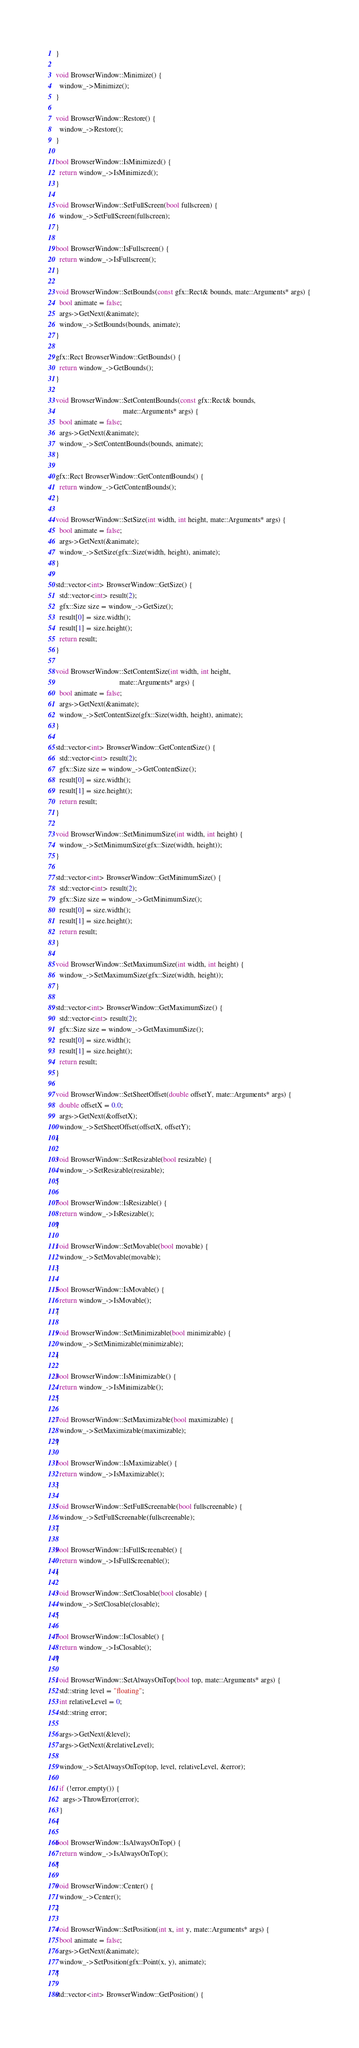Convert code to text. <code><loc_0><loc_0><loc_500><loc_500><_C++_>}

void BrowserWindow::Minimize() {
  window_->Minimize();
}

void BrowserWindow::Restore() {
  window_->Restore();
}

bool BrowserWindow::IsMinimized() {
  return window_->IsMinimized();
}

void BrowserWindow::SetFullScreen(bool fullscreen) {
  window_->SetFullScreen(fullscreen);
}

bool BrowserWindow::IsFullscreen() {
  return window_->IsFullscreen();
}

void BrowserWindow::SetBounds(const gfx::Rect& bounds, mate::Arguments* args) {
  bool animate = false;
  args->GetNext(&animate);
  window_->SetBounds(bounds, animate);
}

gfx::Rect BrowserWindow::GetBounds() {
  return window_->GetBounds();
}

void BrowserWindow::SetContentBounds(const gfx::Rect& bounds,
                                     mate::Arguments* args) {
  bool animate = false;
  args->GetNext(&animate);
  window_->SetContentBounds(bounds, animate);
}

gfx::Rect BrowserWindow::GetContentBounds() {
  return window_->GetContentBounds();
}

void BrowserWindow::SetSize(int width, int height, mate::Arguments* args) {
  bool animate = false;
  args->GetNext(&animate);
  window_->SetSize(gfx::Size(width, height), animate);
}

std::vector<int> BrowserWindow::GetSize() {
  std::vector<int> result(2);
  gfx::Size size = window_->GetSize();
  result[0] = size.width();
  result[1] = size.height();
  return result;
}

void BrowserWindow::SetContentSize(int width, int height,
                                   mate::Arguments* args) {
  bool animate = false;
  args->GetNext(&animate);
  window_->SetContentSize(gfx::Size(width, height), animate);
}

std::vector<int> BrowserWindow::GetContentSize() {
  std::vector<int> result(2);
  gfx::Size size = window_->GetContentSize();
  result[0] = size.width();
  result[1] = size.height();
  return result;
}

void BrowserWindow::SetMinimumSize(int width, int height) {
  window_->SetMinimumSize(gfx::Size(width, height));
}

std::vector<int> BrowserWindow::GetMinimumSize() {
  std::vector<int> result(2);
  gfx::Size size = window_->GetMinimumSize();
  result[0] = size.width();
  result[1] = size.height();
  return result;
}

void BrowserWindow::SetMaximumSize(int width, int height) {
  window_->SetMaximumSize(gfx::Size(width, height));
}

std::vector<int> BrowserWindow::GetMaximumSize() {
  std::vector<int> result(2);
  gfx::Size size = window_->GetMaximumSize();
  result[0] = size.width();
  result[1] = size.height();
  return result;
}

void BrowserWindow::SetSheetOffset(double offsetY, mate::Arguments* args) {
  double offsetX = 0.0;
  args->GetNext(&offsetX);
  window_->SetSheetOffset(offsetX, offsetY);
}

void BrowserWindow::SetResizable(bool resizable) {
  window_->SetResizable(resizable);
}

bool BrowserWindow::IsResizable() {
  return window_->IsResizable();
}

void BrowserWindow::SetMovable(bool movable) {
  window_->SetMovable(movable);
}

bool BrowserWindow::IsMovable() {
  return window_->IsMovable();
}

void BrowserWindow::SetMinimizable(bool minimizable) {
  window_->SetMinimizable(minimizable);
}

bool BrowserWindow::IsMinimizable() {
  return window_->IsMinimizable();
}

void BrowserWindow::SetMaximizable(bool maximizable) {
  window_->SetMaximizable(maximizable);
}

bool BrowserWindow::IsMaximizable() {
  return window_->IsMaximizable();
}

void BrowserWindow::SetFullScreenable(bool fullscreenable) {
  window_->SetFullScreenable(fullscreenable);
}

bool BrowserWindow::IsFullScreenable() {
  return window_->IsFullScreenable();
}

void BrowserWindow::SetClosable(bool closable) {
  window_->SetClosable(closable);
}

bool BrowserWindow::IsClosable() {
  return window_->IsClosable();
}

void BrowserWindow::SetAlwaysOnTop(bool top, mate::Arguments* args) {
  std::string level = "floating";
  int relativeLevel = 0;
  std::string error;

  args->GetNext(&level);
  args->GetNext(&relativeLevel);

  window_->SetAlwaysOnTop(top, level, relativeLevel, &error);

  if (!error.empty()) {
    args->ThrowError(error);
  }
}

bool BrowserWindow::IsAlwaysOnTop() {
  return window_->IsAlwaysOnTop();
}

void BrowserWindow::Center() {
  window_->Center();
}

void BrowserWindow::SetPosition(int x, int y, mate::Arguments* args) {
  bool animate = false;
  args->GetNext(&animate);
  window_->SetPosition(gfx::Point(x, y), animate);
}

std::vector<int> BrowserWindow::GetPosition() {</code> 